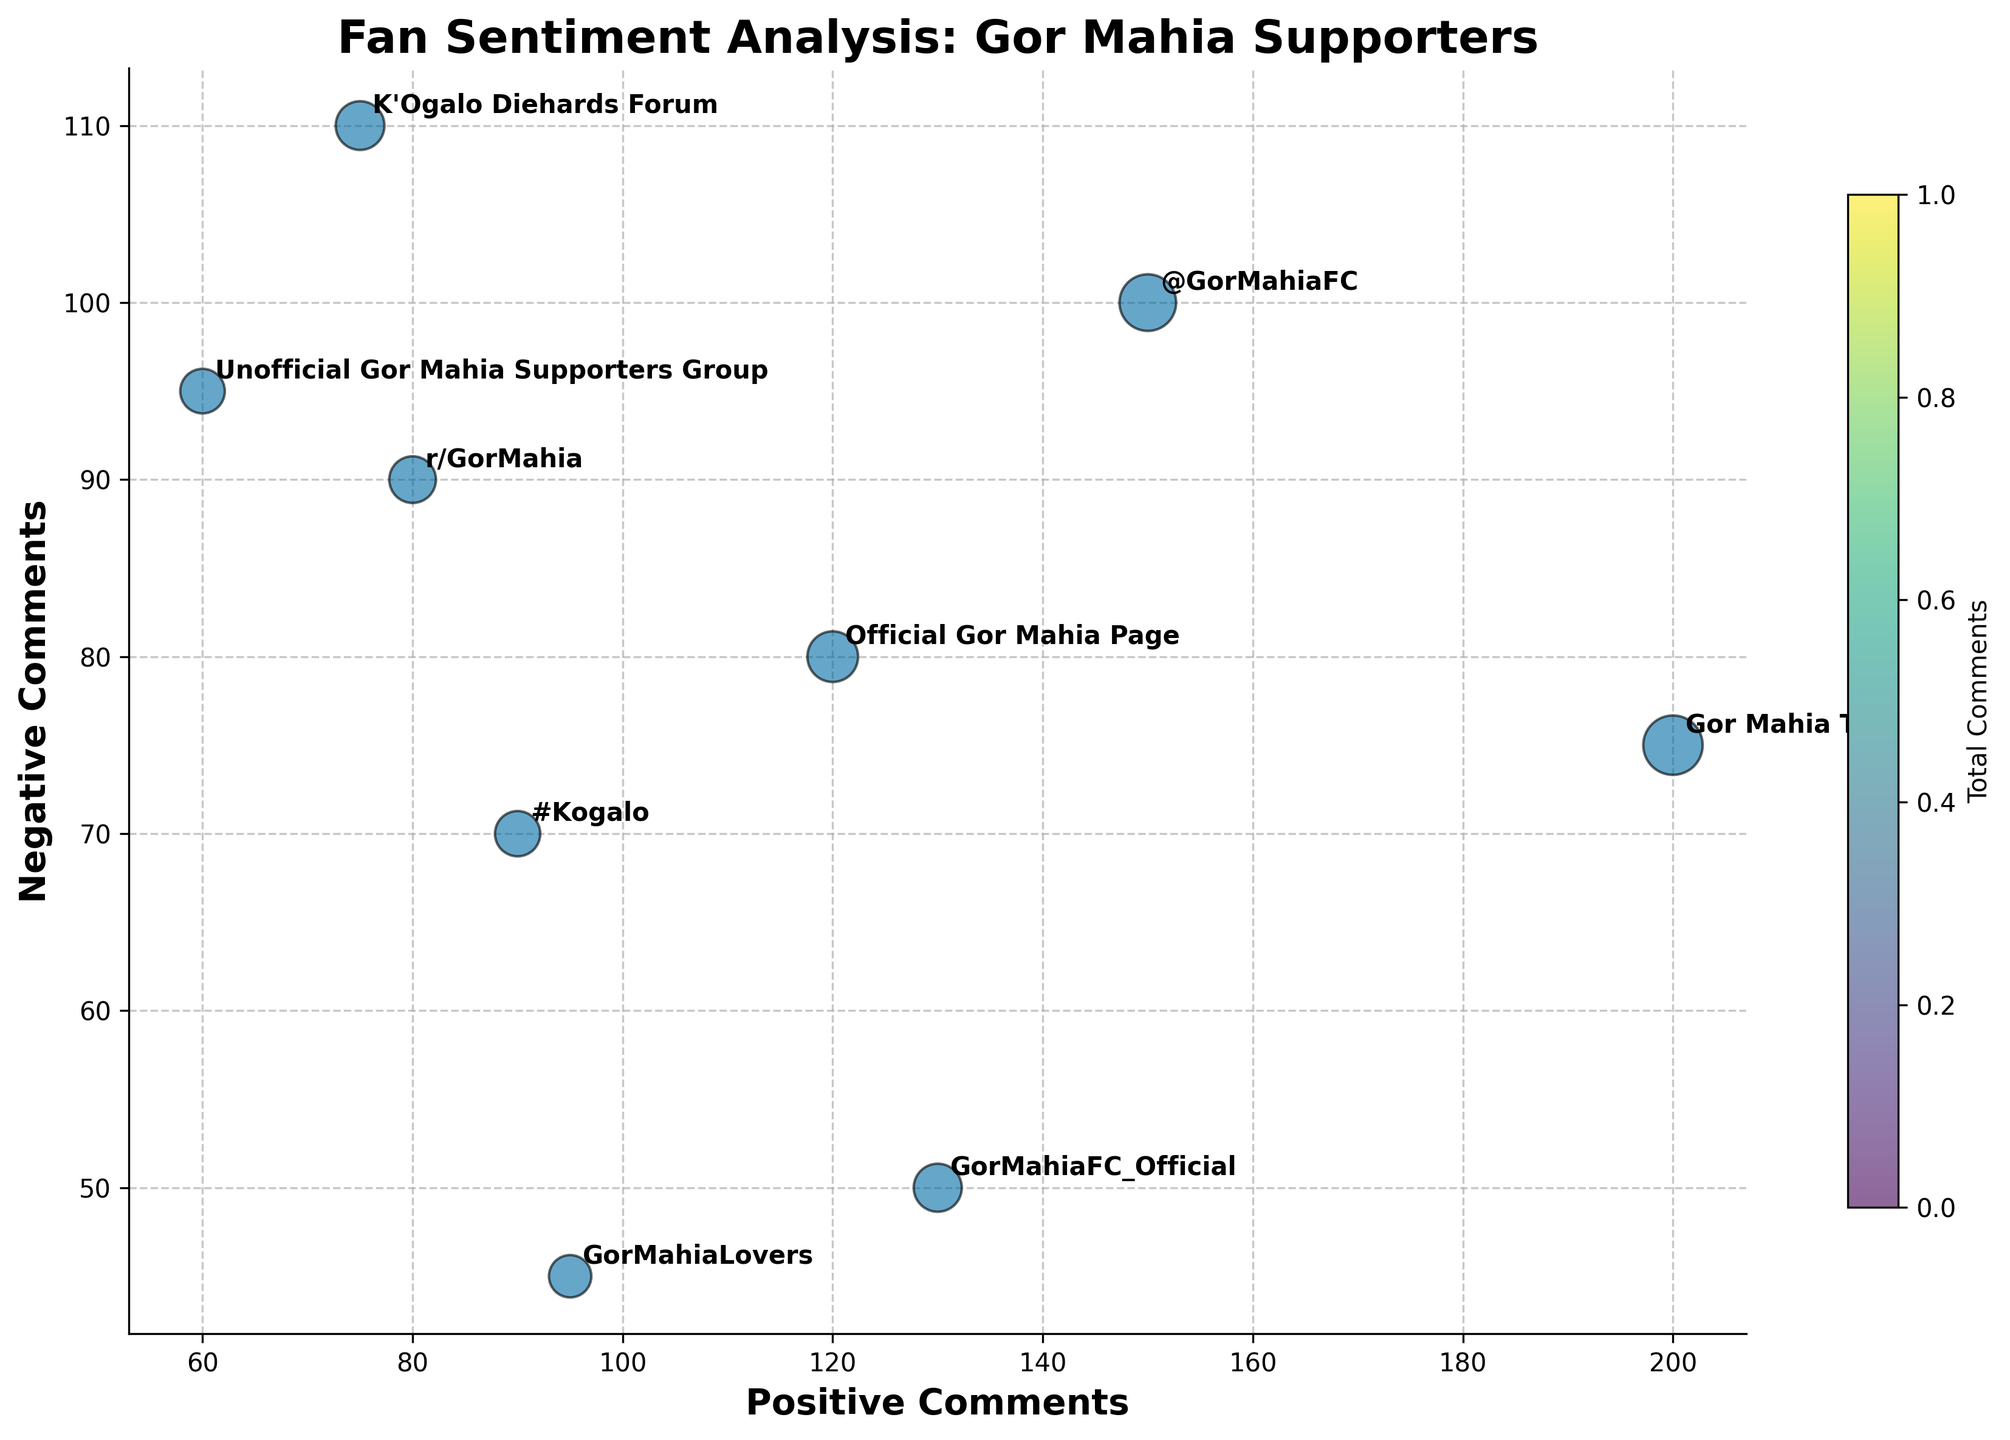How many channels have more positive comments than negative comments? To determine the number of channels with more positive comments than negative ones, inspect each data point and compare the counts. Channels where the count of positive comments is greater include: Official Gor Mahia Page, Twitter @GorMahiaFC, #Kogalo, GorMahiaFC_Official, GorMahiaLovers, and Gor Mahia TV.
Answer: 6 Which social media source has the highest total number of comments? Calculate the total comments for each source by summing the positive and negative comments. The source with the highest total is Gor Mahia TV on YouTube, with 200 positive and 75 negative comments, totaling 275.
Answer: Gor Mahia TV Which source shows the highest negative comments? To find this, compare the negative comments of each source. K'Ogalo Diehards Forum on the Fan Forum has the highest, with 110 negative comments.
Answer: K'Ogalo Diehards Forum What is the average number of positive comments across all channels? Sum the positive comments for all channels and divide by the number of channels. The total positive comments are 1000 (120+60+150+90+75+130+95+80+200), and there are 9 channels, so the average is 1000 / 9 ≈ 111.11.
Answer: 111.11 Compare the fan sentiment on Instagram between GorMahiaFC_Official and GorMahiaLovers. Which one has a better sentiment ratio? To determine the sentiment ratio, divide the positive comments by the negative comments for both sources. GorMahiaFC_Official has a ratio of 130/50 = 2.6, and GorMahiaLovers has a ratio of 95/45 = 2.11. GorMahiaFC_Official has a better sentiment ratio.
Answer: GorMahiaFC_Official Which platform has the least variance in sentiment between positive and negative comments? Calculate the difference between positive and negative comments for each platform. The smallest difference is on GorMahiaFC_Official on Instagram with a difference of 80 (130-50).
Answer: GorMahiaFC_Official How many sources have a higher number of negative comments compared to their positive counterparts? Count each source where negative comments exceed positive comments. The sources are Unofficial Gor Mahia Supporters Group, K'Ogalo Diehards Forum, and r/GorMahia.
Answer: 3 Which Twitter account has fewer negative comments, @GorMahiaFC or #Kogalo? Compare the number of negative comments of the Twitter accounts. @GorMahiaFC has 100 negative comments, while #Kogalo has 70. #Kogalo has fewer negative comments.
Answer: #Kogalo What is the total number of comments from all sources combined? Add up all positive and negative comments across all sources. Total comments: 120+80+60+95+150+100+90+70+75+110+130+50+95+45+80+90+200+75=1490.
Answer: 1490 